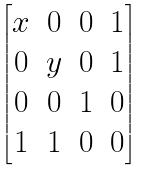Convert formula to latex. <formula><loc_0><loc_0><loc_500><loc_500>\begin{bmatrix} x & 0 & 0 & 1 \\ 0 & y & 0 & 1 \\ 0 & 0 & 1 & 0 \\ 1 & 1 & 0 & 0 \end{bmatrix}</formula> 